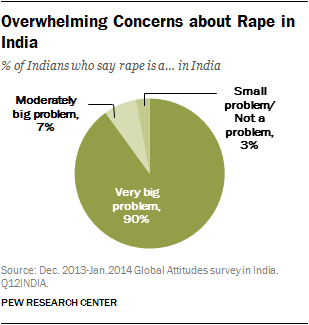What's the ratio of largest segment and sum of two smallest segment? The question appears to be misaligned with the content of the image provided. The pie chart from the PEW Research Center illustrates the perceptions about the severity of the problem of rape in India, with 90% viewing it as a 'Very big problem', 7% as a 'Moderately big problem', and 3% as 'Small problem/Not a problem'. There are no numerical segment ratios to calculate in the context initially suggested by the question. 